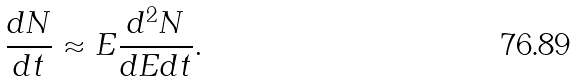<formula> <loc_0><loc_0><loc_500><loc_500>\frac { d N } { d t } \approx E \frac { d ^ { 2 } N } { d E d t } .</formula> 